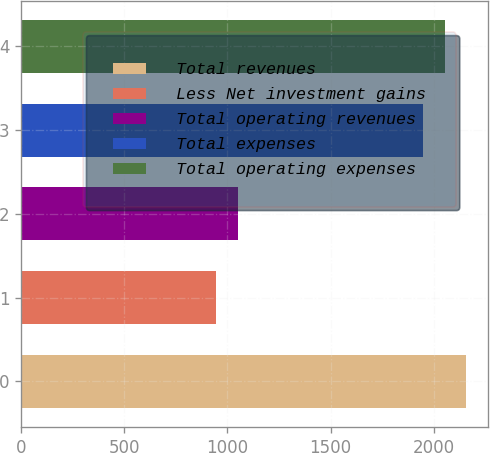<chart> <loc_0><loc_0><loc_500><loc_500><bar_chart><fcel>Total revenues<fcel>Less Net investment gains<fcel>Total operating revenues<fcel>Total expenses<fcel>Total operating expenses<nl><fcel>2155.4<fcel>947<fcel>1050.2<fcel>1949<fcel>2052.2<nl></chart> 